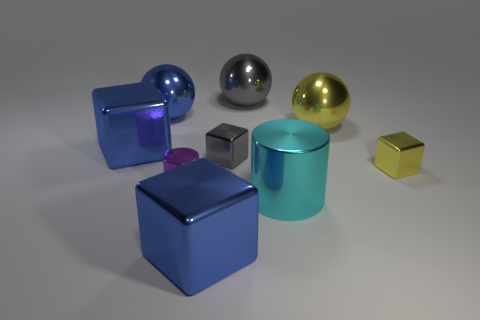Subtract all blocks. How many objects are left? 5 Add 2 big gray spheres. How many big gray spheres exist? 3 Subtract 1 gray balls. How many objects are left? 8 Subtract all large red metal cylinders. Subtract all big cylinders. How many objects are left? 8 Add 7 large cylinders. How many large cylinders are left? 8 